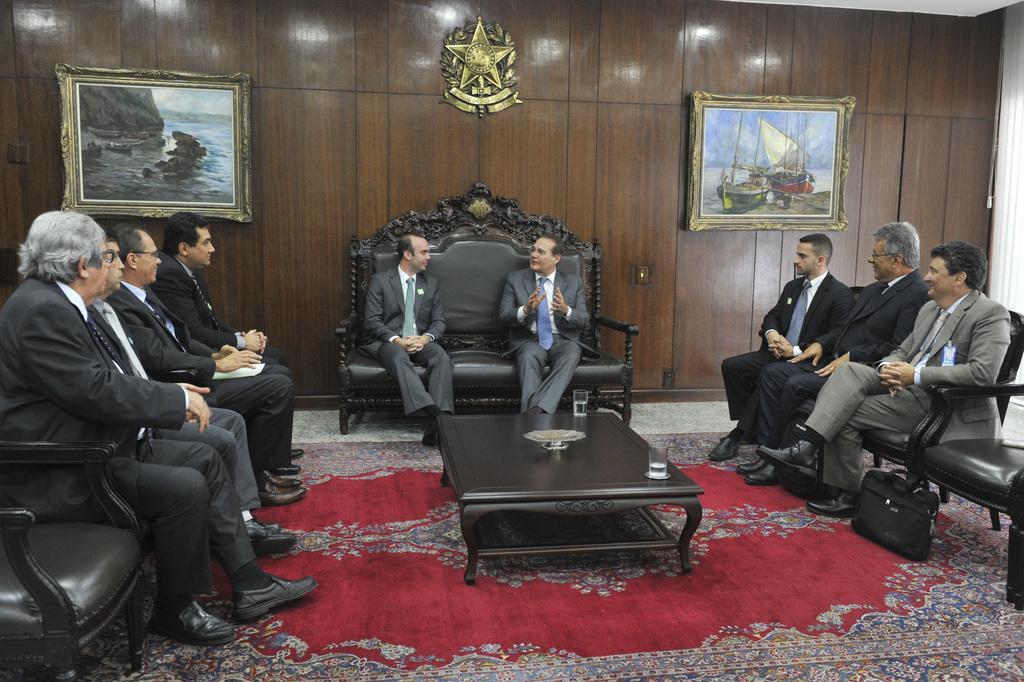How would you summarize this image in a sentence or two? This picture is of inside. On the right there are group of persons sitting on the chairs and there is a bag placed on the ground. On the center there is a table on which two glasses of water is placed, behind the table there are two persons sitting on the sofa and seems to be talking. On the left there are group of people sitting on the chairs. In the background we can see the picture frames hanging on the wall and in the foreground we can see the carpet on the ground. 